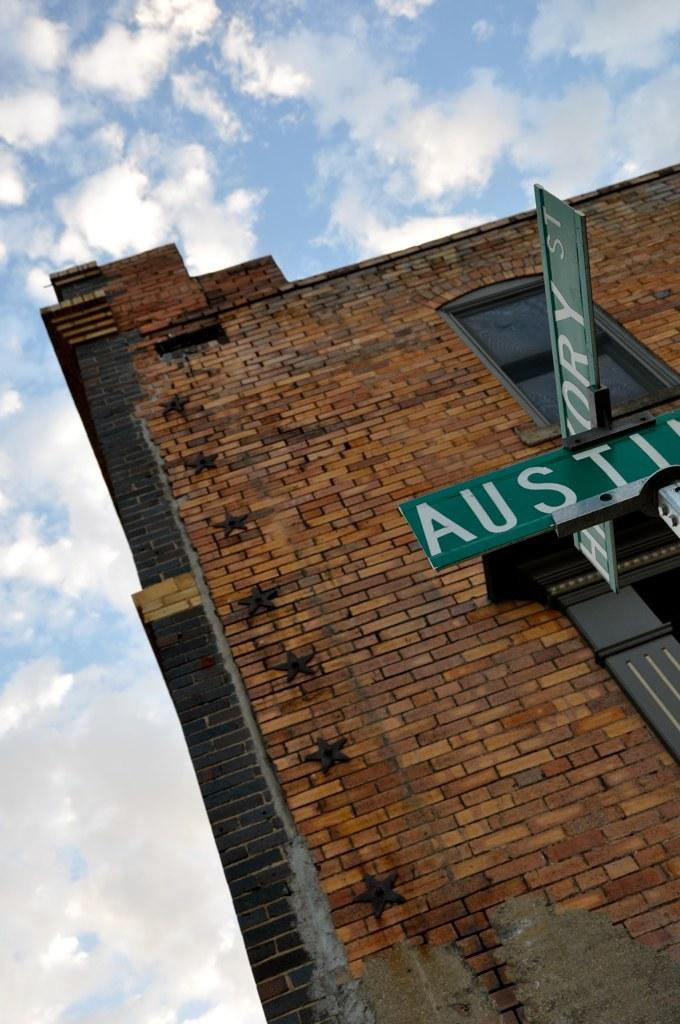What is present on the boards in the image? There are boards with text in the image. What structure is located behind the boards? There is a building behind the boards. What can be seen in the sky at the top of the image? Clouds are visible in the sky at the top of the image. What type of meal is being prepared in the appliance visible in the image? There is no appliance present in the image, and therefore no meal preparation can be observed. 